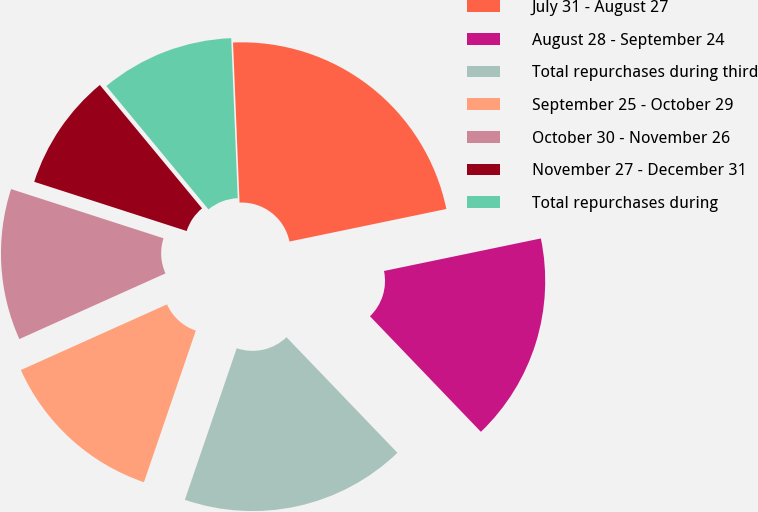Convert chart. <chart><loc_0><loc_0><loc_500><loc_500><pie_chart><fcel>July 31 - August 27<fcel>August 28 - September 24<fcel>Total repurchases during third<fcel>September 25 - October 29<fcel>October 30 - November 26<fcel>November 27 - December 31<fcel>Total repurchases during<nl><fcel>22.39%<fcel>16.08%<fcel>17.42%<fcel>13.03%<fcel>11.69%<fcel>9.02%<fcel>10.36%<nl></chart> 